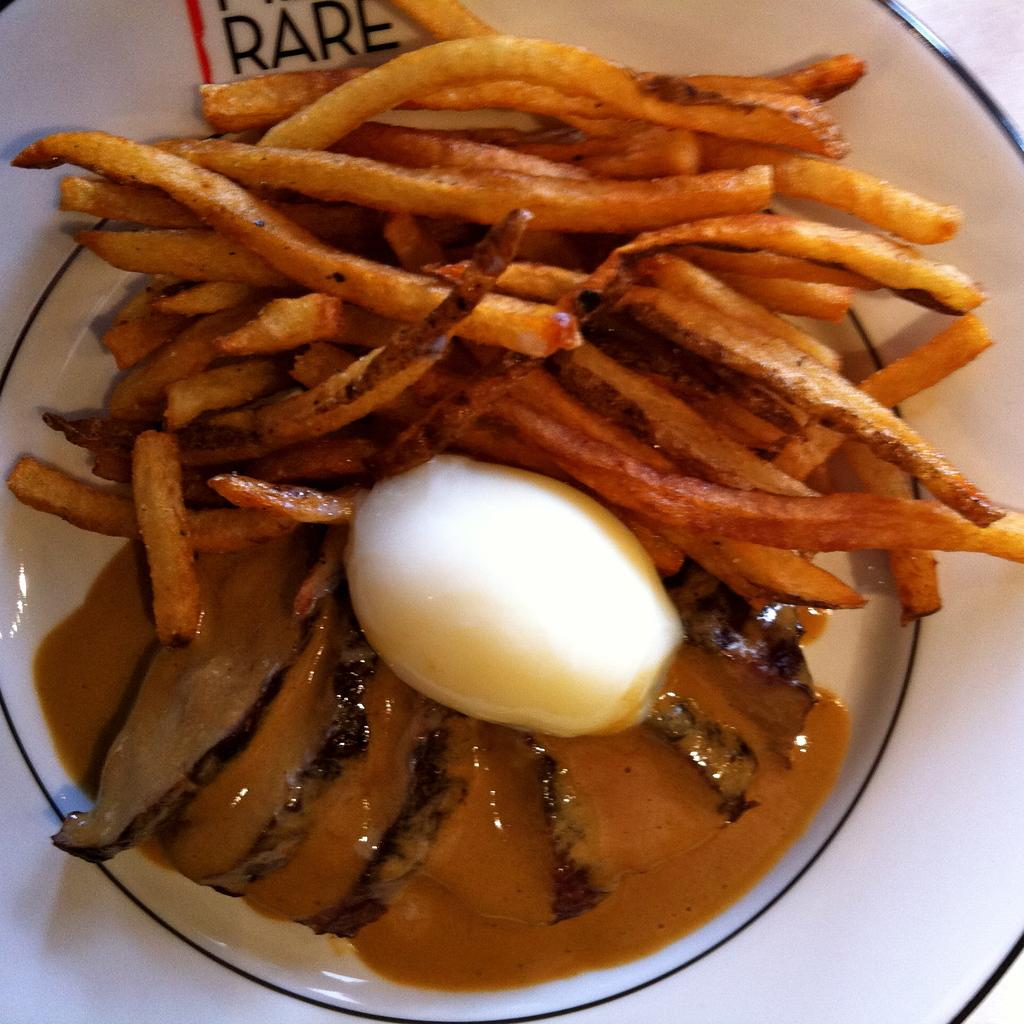What type of food is visible in the image? There are french fries in the image. What accompanies the french fries in the image? There is sauce in the image. What other food item can be seen on a plate in the image? There is an egg on a plate in the image. What type of power source is visible in the image? There is no power source visible in the image; it only features food items. 